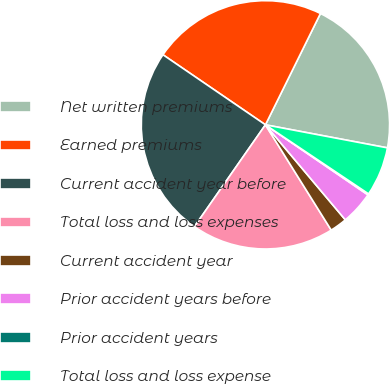Convert chart to OTSL. <chart><loc_0><loc_0><loc_500><loc_500><pie_chart><fcel>Net written premiums<fcel>Earned premiums<fcel>Current accident year before<fcel>Total loss and loss expenses<fcel>Current accident year<fcel>Prior accident years before<fcel>Prior accident years<fcel>Total loss and loss expense<nl><fcel>20.67%<fcel>22.76%<fcel>24.85%<fcel>18.58%<fcel>2.24%<fcel>4.33%<fcel>0.15%<fcel>6.42%<nl></chart> 